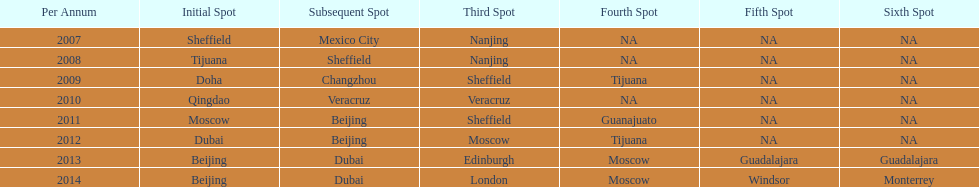In what year was the 3rd venue the same as 2011's 1st venue? 2012. 